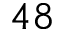<formula> <loc_0><loc_0><loc_500><loc_500>4 8</formula> 